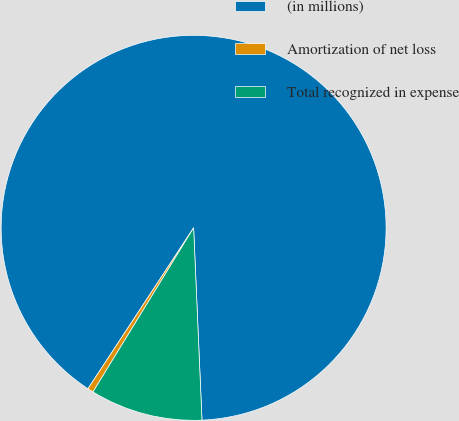Convert chart. <chart><loc_0><loc_0><loc_500><loc_500><pie_chart><fcel>(in millions)<fcel>Amortization of net loss<fcel>Total recognized in expense<nl><fcel>90.06%<fcel>0.49%<fcel>9.45%<nl></chart> 